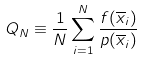Convert formula to latex. <formula><loc_0><loc_0><loc_500><loc_500>Q _ { N } \equiv \frac { 1 } { N } \sum _ { i = 1 } ^ { N } \frac { f ( \overline { x } _ { i } ) } { p ( \overline { x } _ { i } ) }</formula> 